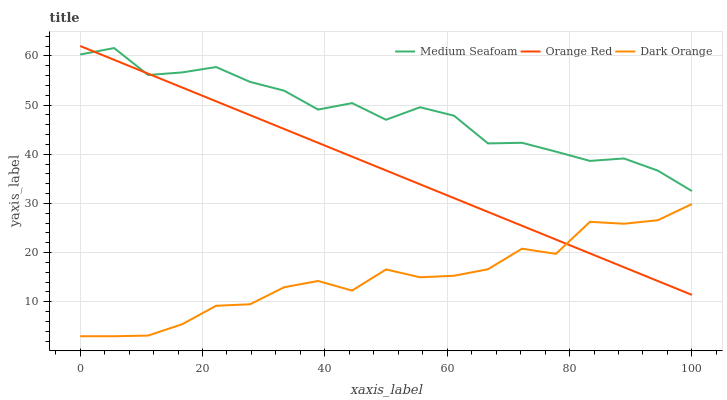Does Dark Orange have the minimum area under the curve?
Answer yes or no. Yes. Does Medium Seafoam have the maximum area under the curve?
Answer yes or no. Yes. Does Orange Red have the minimum area under the curve?
Answer yes or no. No. Does Orange Red have the maximum area under the curve?
Answer yes or no. No. Is Orange Red the smoothest?
Answer yes or no. Yes. Is Medium Seafoam the roughest?
Answer yes or no. Yes. Is Medium Seafoam the smoothest?
Answer yes or no. No. Is Orange Red the roughest?
Answer yes or no. No. Does Dark Orange have the lowest value?
Answer yes or no. Yes. Does Orange Red have the lowest value?
Answer yes or no. No. Does Orange Red have the highest value?
Answer yes or no. Yes. Does Medium Seafoam have the highest value?
Answer yes or no. No. Is Dark Orange less than Medium Seafoam?
Answer yes or no. Yes. Is Medium Seafoam greater than Dark Orange?
Answer yes or no. Yes. Does Orange Red intersect Medium Seafoam?
Answer yes or no. Yes. Is Orange Red less than Medium Seafoam?
Answer yes or no. No. Is Orange Red greater than Medium Seafoam?
Answer yes or no. No. Does Dark Orange intersect Medium Seafoam?
Answer yes or no. No. 